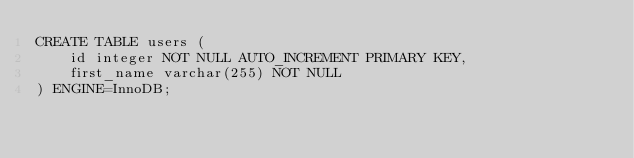<code> <loc_0><loc_0><loc_500><loc_500><_SQL_>CREATE TABLE users (
    id integer NOT NULL AUTO_INCREMENT PRIMARY KEY,
    first_name varchar(255) NOT NULL
) ENGINE=InnoDB;
</code> 